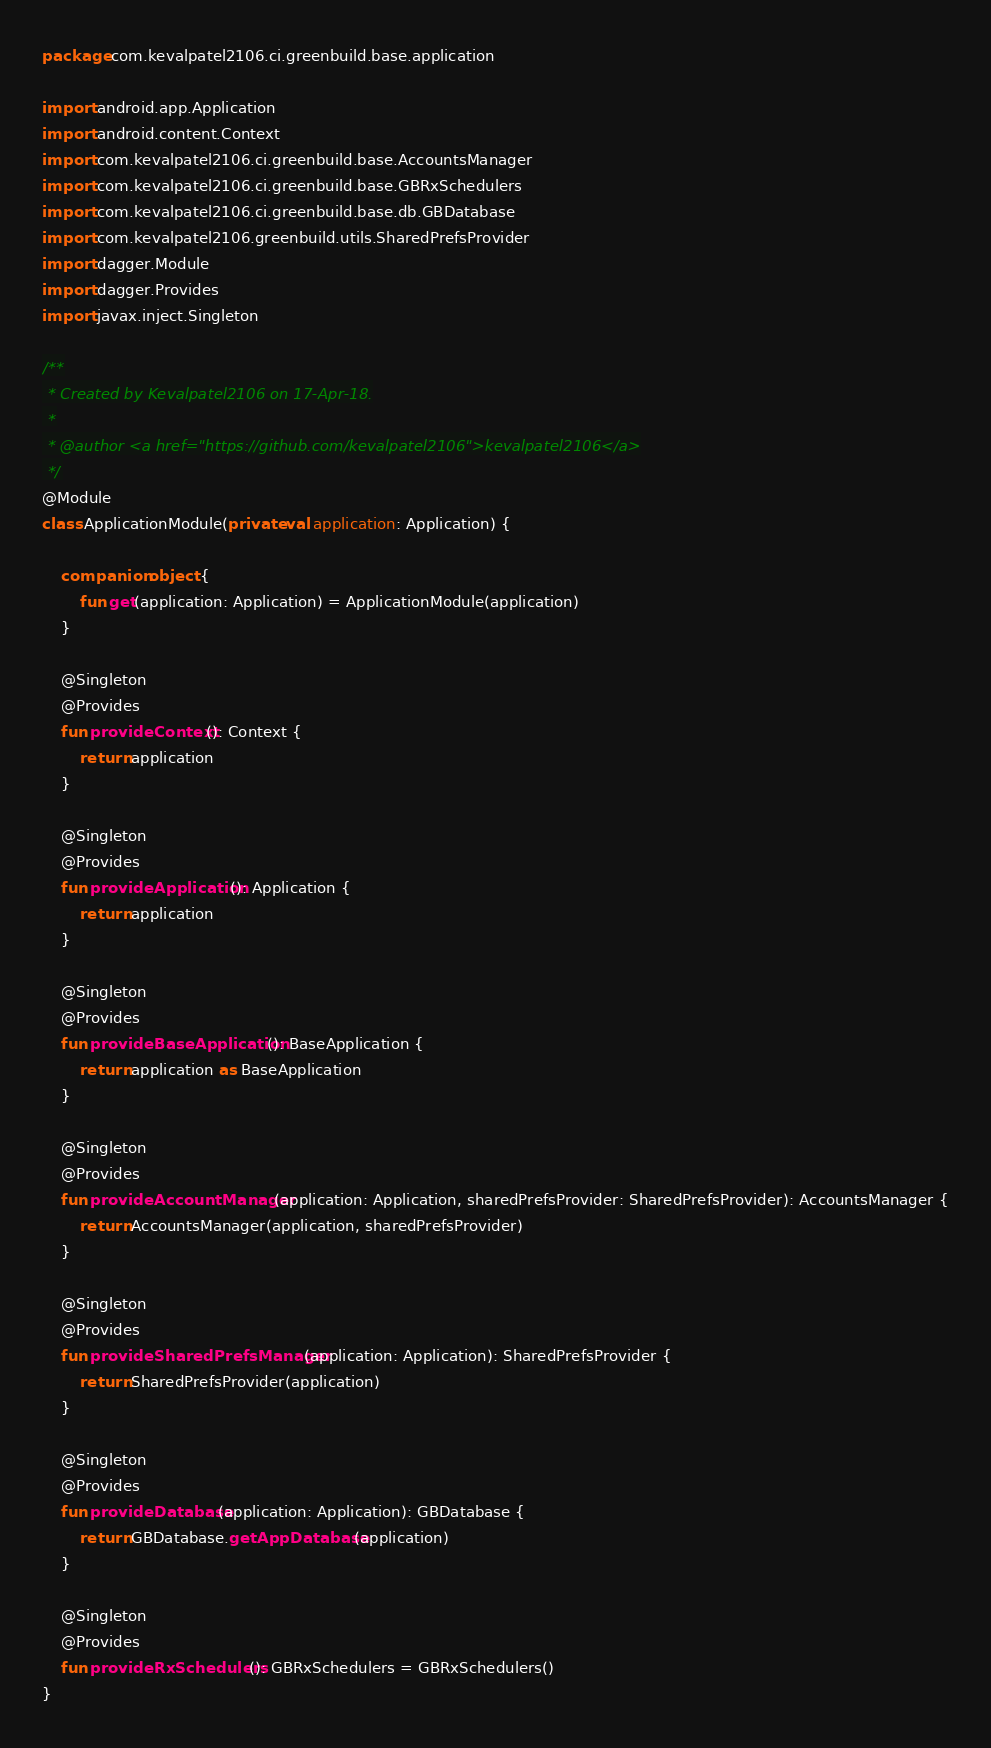<code> <loc_0><loc_0><loc_500><loc_500><_Kotlin_>package com.kevalpatel2106.ci.greenbuild.base.application

import android.app.Application
import android.content.Context
import com.kevalpatel2106.ci.greenbuild.base.AccountsManager
import com.kevalpatel2106.ci.greenbuild.base.GBRxSchedulers
import com.kevalpatel2106.ci.greenbuild.base.db.GBDatabase
import com.kevalpatel2106.greenbuild.utils.SharedPrefsProvider
import dagger.Module
import dagger.Provides
import javax.inject.Singleton

/**
 * Created by Kevalpatel2106 on 17-Apr-18.
 *
 * @author <a href="https://github.com/kevalpatel2106">kevalpatel2106</a>
 */
@Module
class ApplicationModule(private val application: Application) {

    companion object {
        fun get(application: Application) = ApplicationModule(application)
    }

    @Singleton
    @Provides
    fun provideContext(): Context {
        return application
    }

    @Singleton
    @Provides
    fun provideApplication(): Application {
        return application
    }

    @Singleton
    @Provides
    fun provideBaseApplication(): BaseApplication {
        return application as BaseApplication
    }

    @Singleton
    @Provides
    fun provideAccountManager(application: Application, sharedPrefsProvider: SharedPrefsProvider): AccountsManager {
        return AccountsManager(application, sharedPrefsProvider)
    }

    @Singleton
    @Provides
    fun provideSharedPrefsManager(application: Application): SharedPrefsProvider {
        return SharedPrefsProvider(application)
    }

    @Singleton
    @Provides
    fun provideDatabase(application: Application): GBDatabase {
        return GBDatabase.getAppDatabase(application)
    }

    @Singleton
    @Provides
    fun provideRxSchedulers(): GBRxSchedulers = GBRxSchedulers()
}
</code> 